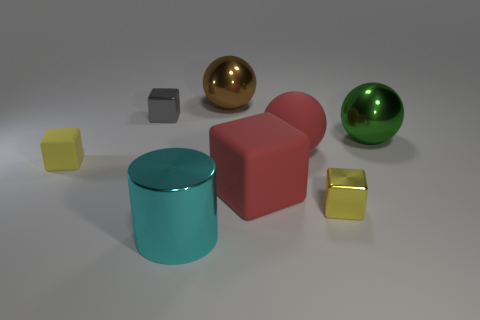Are there fewer rubber blocks than tiny green rubber objects?
Offer a very short reply. No. What is the material of the big sphere that is on the right side of the big brown thing and to the left of the green ball?
Keep it short and to the point. Rubber. What size is the red rubber object that is in front of the yellow thing that is left of the small shiny block that is on the right side of the cyan shiny cylinder?
Ensure brevity in your answer.  Large. There is a large green shiny thing; is its shape the same as the large thing behind the green metal ball?
Keep it short and to the point. Yes. How many things are in front of the small matte object and behind the large cyan metal cylinder?
Ensure brevity in your answer.  2. What number of green objects are metallic blocks or small cubes?
Ensure brevity in your answer.  0. There is a large rubber block that is to the right of the cyan metal cylinder; is it the same color as the big rubber sphere to the right of the large brown thing?
Offer a terse response. Yes. The small shiny block that is left of the tiny metal cube on the right side of the big cyan cylinder left of the large red ball is what color?
Your response must be concise. Gray. There is a tiny metal cube behind the big green metallic thing; is there a thing that is right of it?
Give a very brief answer. Yes. There is a small shiny thing that is on the right side of the brown metal sphere; does it have the same shape as the large green shiny object?
Provide a short and direct response. No. 